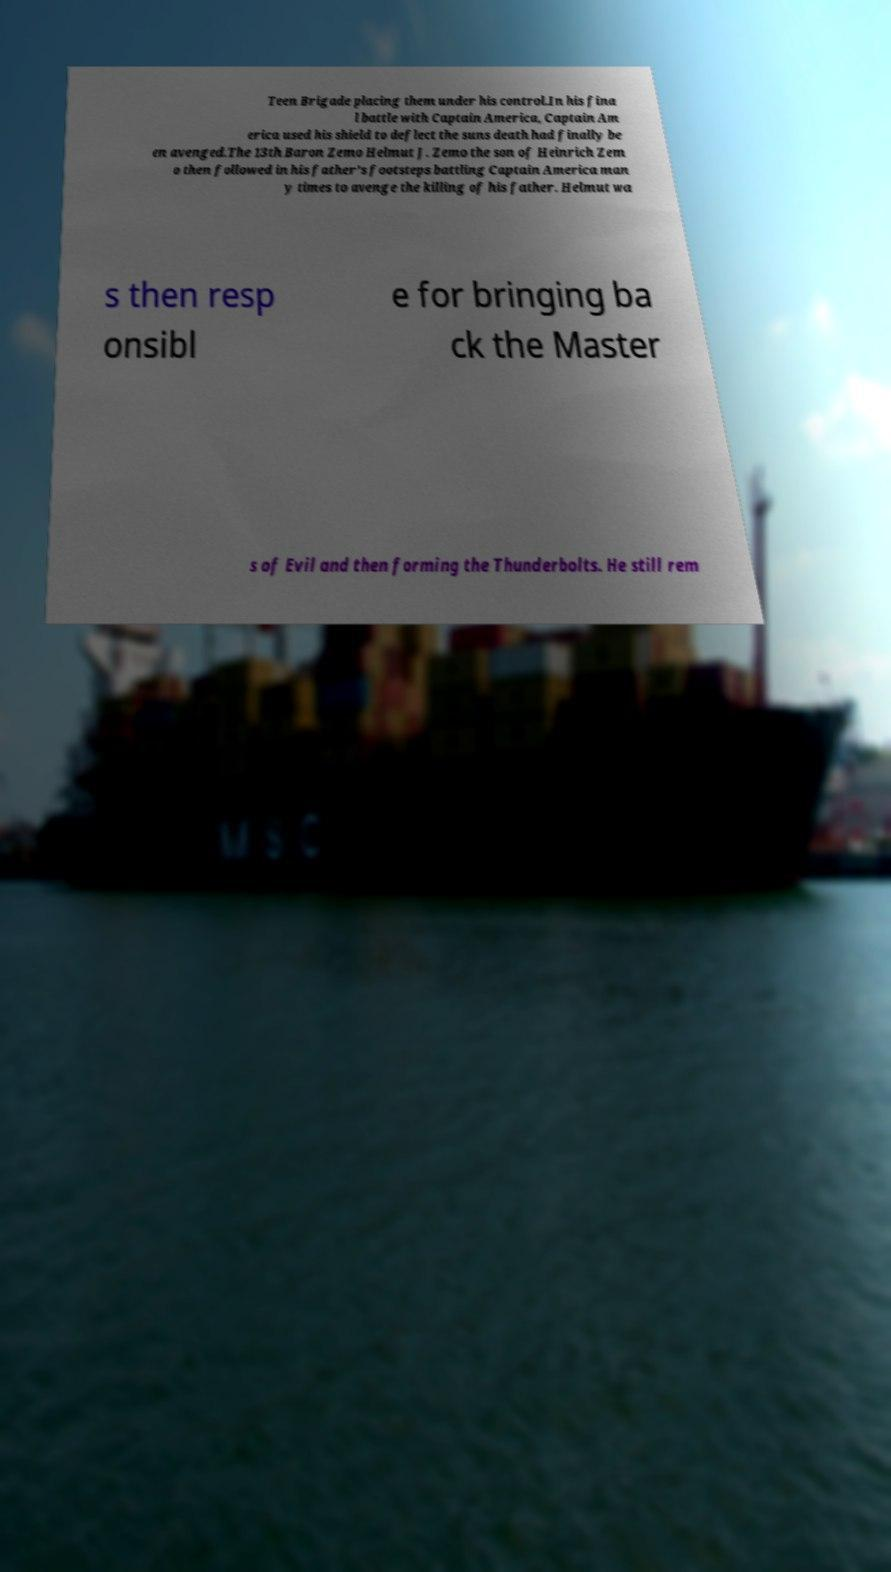Please read and relay the text visible in this image. What does it say? Teen Brigade placing them under his control.In his fina l battle with Captain America, Captain Am erica used his shield to deflect the suns death had finally be en avenged.The 13th Baron Zemo Helmut J. Zemo the son of Heinrich Zem o then followed in his father's footsteps battling Captain America man y times to avenge the killing of his father. Helmut wa s then resp onsibl e for bringing ba ck the Master s of Evil and then forming the Thunderbolts. He still rem 